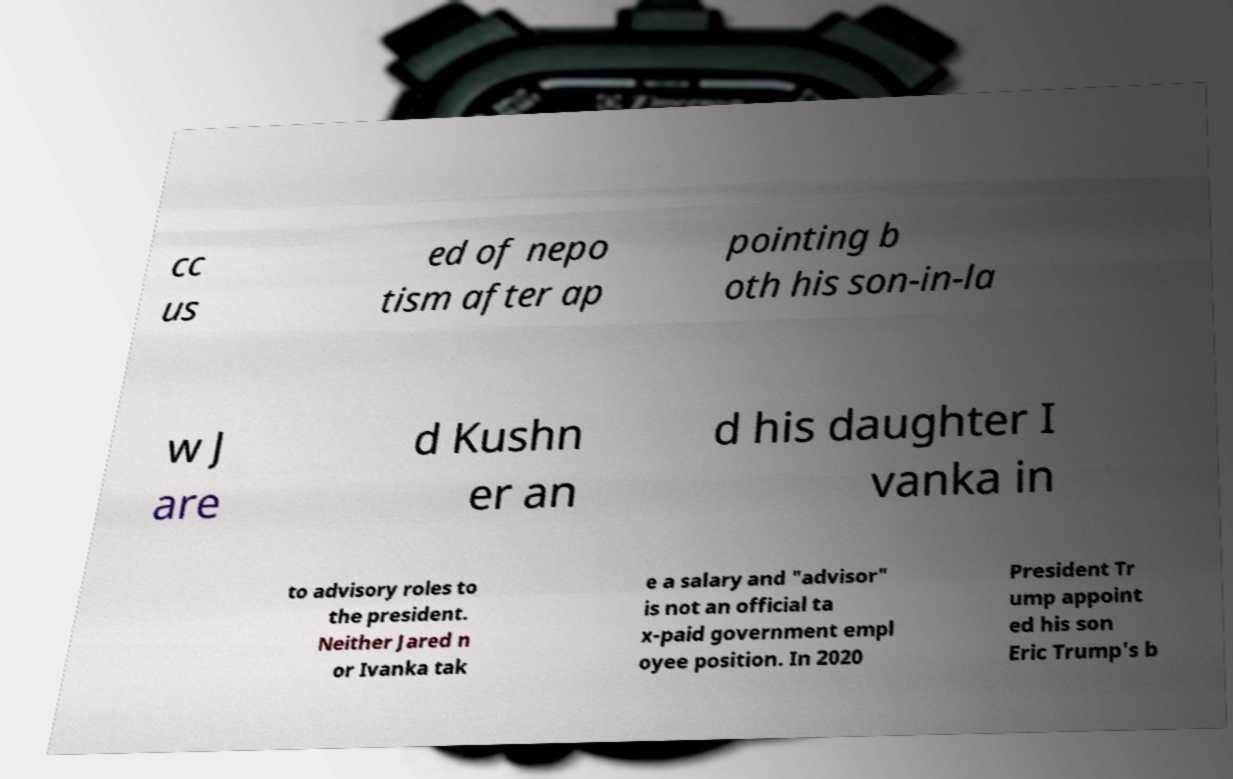Can you read and provide the text displayed in the image?This photo seems to have some interesting text. Can you extract and type it out for me? cc us ed of nepo tism after ap pointing b oth his son-in-la w J are d Kushn er an d his daughter I vanka in to advisory roles to the president. Neither Jared n or Ivanka tak e a salary and "advisor" is not an official ta x-paid government empl oyee position. In 2020 President Tr ump appoint ed his son Eric Trump's b 